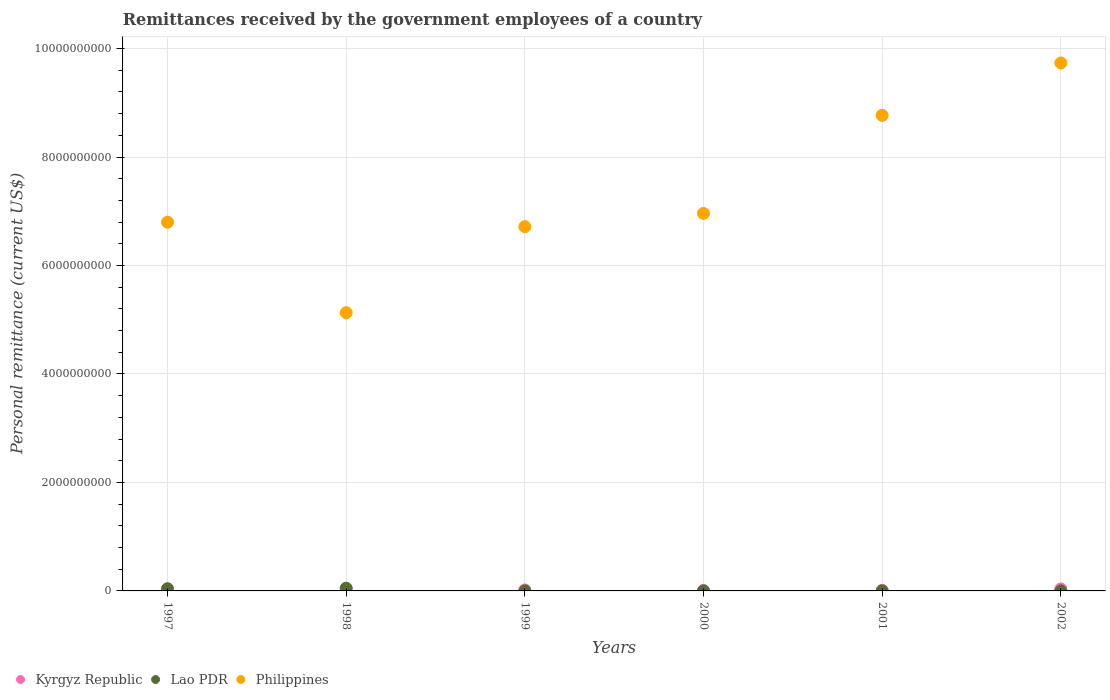How many different coloured dotlines are there?
Make the answer very short. 3. Is the number of dotlines equal to the number of legend labels?
Your response must be concise. Yes. What is the remittances received by the government employees in Philippines in 1999?
Your answer should be compact. 6.72e+09. Across all years, what is the minimum remittances received by the government employees in Lao PDR?
Ensure brevity in your answer.  6.00e+05. In which year was the remittances received by the government employees in Philippines maximum?
Your answer should be compact. 2002. What is the total remittances received by the government employees in Kyrgyz Republic in the graph?
Offer a terse response. 1.03e+08. What is the difference between the remittances received by the government employees in Philippines in 1997 and that in 1999?
Your answer should be very brief. 8.20e+07. What is the difference between the remittances received by the government employees in Philippines in 1999 and the remittances received by the government employees in Kyrgyz Republic in 2001?
Your answer should be very brief. 6.71e+09. What is the average remittances received by the government employees in Kyrgyz Republic per year?
Provide a succinct answer. 1.71e+07. In the year 1997, what is the difference between the remittances received by the government employees in Philippines and remittances received by the government employees in Lao PDR?
Ensure brevity in your answer.  6.76e+09. What is the ratio of the remittances received by the government employees in Kyrgyz Republic in 1997 to that in 2000?
Offer a very short reply. 0.31. Is the difference between the remittances received by the government employees in Philippines in 1997 and 2001 greater than the difference between the remittances received by the government employees in Lao PDR in 1997 and 2001?
Your response must be concise. No. What is the difference between the highest and the second highest remittances received by the government employees in Philippines?
Offer a very short reply. 9.66e+08. What is the difference between the highest and the lowest remittances received by the government employees in Kyrgyz Republic?
Ensure brevity in your answer.  3.40e+07. Is the remittances received by the government employees in Philippines strictly greater than the remittances received by the government employees in Kyrgyz Republic over the years?
Provide a short and direct response. Yes. Is the remittances received by the government employees in Lao PDR strictly less than the remittances received by the government employees in Philippines over the years?
Ensure brevity in your answer.  Yes. How many dotlines are there?
Make the answer very short. 3. How many years are there in the graph?
Give a very brief answer. 6. Are the values on the major ticks of Y-axis written in scientific E-notation?
Offer a terse response. No. Does the graph contain any zero values?
Ensure brevity in your answer.  No. How are the legend labels stacked?
Your answer should be compact. Horizontal. What is the title of the graph?
Provide a short and direct response. Remittances received by the government employees of a country. Does "West Bank and Gaza" appear as one of the legend labels in the graph?
Your answer should be compact. No. What is the label or title of the X-axis?
Your answer should be very brief. Years. What is the label or title of the Y-axis?
Offer a terse response. Personal remittance (current US$). What is the Personal remittance (current US$) of Kyrgyz Republic in 1997?
Ensure brevity in your answer.  2.74e+06. What is the Personal remittance (current US$) of Lao PDR in 1997?
Keep it short and to the point. 4.08e+07. What is the Personal remittance (current US$) of Philippines in 1997?
Keep it short and to the point. 6.80e+09. What is the Personal remittance (current US$) in Kyrgyz Republic in 1998?
Your answer should be very brief. 2.47e+07. What is the Personal remittance (current US$) of Philippines in 1998?
Your response must be concise. 5.13e+09. What is the Personal remittance (current US$) of Kyrgyz Republic in 1999?
Provide a succinct answer. 1.85e+07. What is the Personal remittance (current US$) in Lao PDR in 1999?
Make the answer very short. 6.00e+05. What is the Personal remittance (current US$) in Philippines in 1999?
Ensure brevity in your answer.  6.72e+09. What is the Personal remittance (current US$) of Kyrgyz Republic in 2000?
Your response must be concise. 8.84e+06. What is the Personal remittance (current US$) of Lao PDR in 2000?
Offer a very short reply. 6.60e+05. What is the Personal remittance (current US$) of Philippines in 2000?
Keep it short and to the point. 6.96e+09. What is the Personal remittance (current US$) in Kyrgyz Republic in 2001?
Your answer should be very brief. 1.11e+07. What is the Personal remittance (current US$) of Lao PDR in 2001?
Give a very brief answer. 6.95e+05. What is the Personal remittance (current US$) in Philippines in 2001?
Provide a short and direct response. 8.77e+09. What is the Personal remittance (current US$) in Kyrgyz Republic in 2002?
Make the answer very short. 3.67e+07. What is the Personal remittance (current US$) of Lao PDR in 2002?
Ensure brevity in your answer.  7.29e+05. What is the Personal remittance (current US$) in Philippines in 2002?
Offer a very short reply. 9.74e+09. Across all years, what is the maximum Personal remittance (current US$) in Kyrgyz Republic?
Your response must be concise. 3.67e+07. Across all years, what is the maximum Personal remittance (current US$) in Lao PDR?
Make the answer very short. 5.00e+07. Across all years, what is the maximum Personal remittance (current US$) in Philippines?
Keep it short and to the point. 9.74e+09. Across all years, what is the minimum Personal remittance (current US$) in Kyrgyz Republic?
Give a very brief answer. 2.74e+06. Across all years, what is the minimum Personal remittance (current US$) of Lao PDR?
Ensure brevity in your answer.  6.00e+05. Across all years, what is the minimum Personal remittance (current US$) in Philippines?
Keep it short and to the point. 5.13e+09. What is the total Personal remittance (current US$) of Kyrgyz Republic in the graph?
Offer a very short reply. 1.03e+08. What is the total Personal remittance (current US$) in Lao PDR in the graph?
Offer a terse response. 9.35e+07. What is the total Personal remittance (current US$) in Philippines in the graph?
Make the answer very short. 4.41e+1. What is the difference between the Personal remittance (current US$) of Kyrgyz Republic in 1997 and that in 1998?
Make the answer very short. -2.20e+07. What is the difference between the Personal remittance (current US$) in Lao PDR in 1997 and that in 1998?
Your response must be concise. -9.20e+06. What is the difference between the Personal remittance (current US$) in Philippines in 1997 and that in 1998?
Provide a succinct answer. 1.67e+09. What is the difference between the Personal remittance (current US$) of Kyrgyz Republic in 1997 and that in 1999?
Your answer should be very brief. -1.57e+07. What is the difference between the Personal remittance (current US$) of Lao PDR in 1997 and that in 1999?
Give a very brief answer. 4.02e+07. What is the difference between the Personal remittance (current US$) of Philippines in 1997 and that in 1999?
Offer a very short reply. 8.20e+07. What is the difference between the Personal remittance (current US$) of Kyrgyz Republic in 1997 and that in 2000?
Provide a short and direct response. -6.10e+06. What is the difference between the Personal remittance (current US$) of Lao PDR in 1997 and that in 2000?
Provide a short and direct response. 4.01e+07. What is the difference between the Personal remittance (current US$) of Philippines in 1997 and that in 2000?
Keep it short and to the point. -1.62e+08. What is the difference between the Personal remittance (current US$) of Kyrgyz Republic in 1997 and that in 2001?
Offer a very short reply. -8.37e+06. What is the difference between the Personal remittance (current US$) of Lao PDR in 1997 and that in 2001?
Keep it short and to the point. 4.01e+07. What is the difference between the Personal remittance (current US$) in Philippines in 1997 and that in 2001?
Your answer should be compact. -1.97e+09. What is the difference between the Personal remittance (current US$) of Kyrgyz Republic in 1997 and that in 2002?
Offer a very short reply. -3.40e+07. What is the difference between the Personal remittance (current US$) in Lao PDR in 1997 and that in 2002?
Ensure brevity in your answer.  4.01e+07. What is the difference between the Personal remittance (current US$) of Philippines in 1997 and that in 2002?
Keep it short and to the point. -2.94e+09. What is the difference between the Personal remittance (current US$) in Kyrgyz Republic in 1998 and that in 1999?
Your answer should be compact. 6.22e+06. What is the difference between the Personal remittance (current US$) in Lao PDR in 1998 and that in 1999?
Provide a short and direct response. 4.94e+07. What is the difference between the Personal remittance (current US$) of Philippines in 1998 and that in 1999?
Offer a terse response. -1.59e+09. What is the difference between the Personal remittance (current US$) of Kyrgyz Republic in 1998 and that in 2000?
Your response must be concise. 1.59e+07. What is the difference between the Personal remittance (current US$) of Lao PDR in 1998 and that in 2000?
Your answer should be very brief. 4.93e+07. What is the difference between the Personal remittance (current US$) in Philippines in 1998 and that in 2000?
Provide a short and direct response. -1.83e+09. What is the difference between the Personal remittance (current US$) in Kyrgyz Republic in 1998 and that in 2001?
Provide a succinct answer. 1.36e+07. What is the difference between the Personal remittance (current US$) of Lao PDR in 1998 and that in 2001?
Offer a terse response. 4.93e+07. What is the difference between the Personal remittance (current US$) in Philippines in 1998 and that in 2001?
Your answer should be compact. -3.64e+09. What is the difference between the Personal remittance (current US$) of Kyrgyz Republic in 1998 and that in 2002?
Offer a terse response. -1.20e+07. What is the difference between the Personal remittance (current US$) of Lao PDR in 1998 and that in 2002?
Offer a very short reply. 4.93e+07. What is the difference between the Personal remittance (current US$) in Philippines in 1998 and that in 2002?
Provide a succinct answer. -4.60e+09. What is the difference between the Personal remittance (current US$) in Kyrgyz Republic in 1999 and that in 2000?
Provide a succinct answer. 9.63e+06. What is the difference between the Personal remittance (current US$) of Lao PDR in 1999 and that in 2000?
Offer a terse response. -6.00e+04. What is the difference between the Personal remittance (current US$) in Philippines in 1999 and that in 2000?
Offer a very short reply. -2.44e+08. What is the difference between the Personal remittance (current US$) in Kyrgyz Republic in 1999 and that in 2001?
Provide a succinct answer. 7.36e+06. What is the difference between the Personal remittance (current US$) in Lao PDR in 1999 and that in 2001?
Give a very brief answer. -9.46e+04. What is the difference between the Personal remittance (current US$) of Philippines in 1999 and that in 2001?
Give a very brief answer. -2.05e+09. What is the difference between the Personal remittance (current US$) in Kyrgyz Republic in 1999 and that in 2002?
Keep it short and to the point. -1.82e+07. What is the difference between the Personal remittance (current US$) in Lao PDR in 1999 and that in 2002?
Your response must be concise. -1.29e+05. What is the difference between the Personal remittance (current US$) in Philippines in 1999 and that in 2002?
Ensure brevity in your answer.  -3.02e+09. What is the difference between the Personal remittance (current US$) in Kyrgyz Republic in 2000 and that in 2001?
Keep it short and to the point. -2.27e+06. What is the difference between the Personal remittance (current US$) of Lao PDR in 2000 and that in 2001?
Keep it short and to the point. -3.46e+04. What is the difference between the Personal remittance (current US$) in Philippines in 2000 and that in 2001?
Make the answer very short. -1.81e+09. What is the difference between the Personal remittance (current US$) in Kyrgyz Republic in 2000 and that in 2002?
Your answer should be compact. -2.79e+07. What is the difference between the Personal remittance (current US$) in Lao PDR in 2000 and that in 2002?
Keep it short and to the point. -6.93e+04. What is the difference between the Personal remittance (current US$) of Philippines in 2000 and that in 2002?
Keep it short and to the point. -2.77e+09. What is the difference between the Personal remittance (current US$) in Kyrgyz Republic in 2001 and that in 2002?
Keep it short and to the point. -2.56e+07. What is the difference between the Personal remittance (current US$) of Lao PDR in 2001 and that in 2002?
Keep it short and to the point. -3.47e+04. What is the difference between the Personal remittance (current US$) of Philippines in 2001 and that in 2002?
Ensure brevity in your answer.  -9.66e+08. What is the difference between the Personal remittance (current US$) of Kyrgyz Republic in 1997 and the Personal remittance (current US$) of Lao PDR in 1998?
Ensure brevity in your answer.  -4.73e+07. What is the difference between the Personal remittance (current US$) of Kyrgyz Republic in 1997 and the Personal remittance (current US$) of Philippines in 1998?
Keep it short and to the point. -5.13e+09. What is the difference between the Personal remittance (current US$) of Lao PDR in 1997 and the Personal remittance (current US$) of Philippines in 1998?
Make the answer very short. -5.09e+09. What is the difference between the Personal remittance (current US$) of Kyrgyz Republic in 1997 and the Personal remittance (current US$) of Lao PDR in 1999?
Your response must be concise. 2.14e+06. What is the difference between the Personal remittance (current US$) in Kyrgyz Republic in 1997 and the Personal remittance (current US$) in Philippines in 1999?
Your response must be concise. -6.71e+09. What is the difference between the Personal remittance (current US$) of Lao PDR in 1997 and the Personal remittance (current US$) of Philippines in 1999?
Make the answer very short. -6.68e+09. What is the difference between the Personal remittance (current US$) of Kyrgyz Republic in 1997 and the Personal remittance (current US$) of Lao PDR in 2000?
Ensure brevity in your answer.  2.08e+06. What is the difference between the Personal remittance (current US$) of Kyrgyz Republic in 1997 and the Personal remittance (current US$) of Philippines in 2000?
Your answer should be compact. -6.96e+09. What is the difference between the Personal remittance (current US$) in Lao PDR in 1997 and the Personal remittance (current US$) in Philippines in 2000?
Provide a succinct answer. -6.92e+09. What is the difference between the Personal remittance (current US$) of Kyrgyz Republic in 1997 and the Personal remittance (current US$) of Lao PDR in 2001?
Offer a very short reply. 2.05e+06. What is the difference between the Personal remittance (current US$) of Kyrgyz Republic in 1997 and the Personal remittance (current US$) of Philippines in 2001?
Offer a very short reply. -8.77e+09. What is the difference between the Personal remittance (current US$) in Lao PDR in 1997 and the Personal remittance (current US$) in Philippines in 2001?
Keep it short and to the point. -8.73e+09. What is the difference between the Personal remittance (current US$) of Kyrgyz Republic in 1997 and the Personal remittance (current US$) of Lao PDR in 2002?
Give a very brief answer. 2.01e+06. What is the difference between the Personal remittance (current US$) in Kyrgyz Republic in 1997 and the Personal remittance (current US$) in Philippines in 2002?
Keep it short and to the point. -9.73e+09. What is the difference between the Personal remittance (current US$) in Lao PDR in 1997 and the Personal remittance (current US$) in Philippines in 2002?
Offer a terse response. -9.69e+09. What is the difference between the Personal remittance (current US$) in Kyrgyz Republic in 1998 and the Personal remittance (current US$) in Lao PDR in 1999?
Give a very brief answer. 2.41e+07. What is the difference between the Personal remittance (current US$) of Kyrgyz Republic in 1998 and the Personal remittance (current US$) of Philippines in 1999?
Your response must be concise. -6.69e+09. What is the difference between the Personal remittance (current US$) in Lao PDR in 1998 and the Personal remittance (current US$) in Philippines in 1999?
Provide a short and direct response. -6.67e+09. What is the difference between the Personal remittance (current US$) of Kyrgyz Republic in 1998 and the Personal remittance (current US$) of Lao PDR in 2000?
Provide a succinct answer. 2.40e+07. What is the difference between the Personal remittance (current US$) of Kyrgyz Republic in 1998 and the Personal remittance (current US$) of Philippines in 2000?
Your response must be concise. -6.94e+09. What is the difference between the Personal remittance (current US$) in Lao PDR in 1998 and the Personal remittance (current US$) in Philippines in 2000?
Make the answer very short. -6.91e+09. What is the difference between the Personal remittance (current US$) of Kyrgyz Republic in 1998 and the Personal remittance (current US$) of Lao PDR in 2001?
Ensure brevity in your answer.  2.40e+07. What is the difference between the Personal remittance (current US$) of Kyrgyz Republic in 1998 and the Personal remittance (current US$) of Philippines in 2001?
Ensure brevity in your answer.  -8.74e+09. What is the difference between the Personal remittance (current US$) in Lao PDR in 1998 and the Personal remittance (current US$) in Philippines in 2001?
Give a very brief answer. -8.72e+09. What is the difference between the Personal remittance (current US$) of Kyrgyz Republic in 1998 and the Personal remittance (current US$) of Lao PDR in 2002?
Your response must be concise. 2.40e+07. What is the difference between the Personal remittance (current US$) of Kyrgyz Republic in 1998 and the Personal remittance (current US$) of Philippines in 2002?
Offer a terse response. -9.71e+09. What is the difference between the Personal remittance (current US$) in Lao PDR in 1998 and the Personal remittance (current US$) in Philippines in 2002?
Offer a terse response. -9.68e+09. What is the difference between the Personal remittance (current US$) of Kyrgyz Republic in 1999 and the Personal remittance (current US$) of Lao PDR in 2000?
Offer a terse response. 1.78e+07. What is the difference between the Personal remittance (current US$) of Kyrgyz Republic in 1999 and the Personal remittance (current US$) of Philippines in 2000?
Your response must be concise. -6.94e+09. What is the difference between the Personal remittance (current US$) in Lao PDR in 1999 and the Personal remittance (current US$) in Philippines in 2000?
Ensure brevity in your answer.  -6.96e+09. What is the difference between the Personal remittance (current US$) of Kyrgyz Republic in 1999 and the Personal remittance (current US$) of Lao PDR in 2001?
Make the answer very short. 1.78e+07. What is the difference between the Personal remittance (current US$) of Kyrgyz Republic in 1999 and the Personal remittance (current US$) of Philippines in 2001?
Keep it short and to the point. -8.75e+09. What is the difference between the Personal remittance (current US$) of Lao PDR in 1999 and the Personal remittance (current US$) of Philippines in 2001?
Make the answer very short. -8.77e+09. What is the difference between the Personal remittance (current US$) in Kyrgyz Republic in 1999 and the Personal remittance (current US$) in Lao PDR in 2002?
Your answer should be compact. 1.77e+07. What is the difference between the Personal remittance (current US$) of Kyrgyz Republic in 1999 and the Personal remittance (current US$) of Philippines in 2002?
Offer a very short reply. -9.72e+09. What is the difference between the Personal remittance (current US$) of Lao PDR in 1999 and the Personal remittance (current US$) of Philippines in 2002?
Offer a terse response. -9.73e+09. What is the difference between the Personal remittance (current US$) in Kyrgyz Republic in 2000 and the Personal remittance (current US$) in Lao PDR in 2001?
Provide a short and direct response. 8.15e+06. What is the difference between the Personal remittance (current US$) in Kyrgyz Republic in 2000 and the Personal remittance (current US$) in Philippines in 2001?
Offer a terse response. -8.76e+09. What is the difference between the Personal remittance (current US$) in Lao PDR in 2000 and the Personal remittance (current US$) in Philippines in 2001?
Your answer should be compact. -8.77e+09. What is the difference between the Personal remittance (current US$) of Kyrgyz Republic in 2000 and the Personal remittance (current US$) of Lao PDR in 2002?
Offer a terse response. 8.12e+06. What is the difference between the Personal remittance (current US$) of Kyrgyz Republic in 2000 and the Personal remittance (current US$) of Philippines in 2002?
Your answer should be very brief. -9.73e+09. What is the difference between the Personal remittance (current US$) in Lao PDR in 2000 and the Personal remittance (current US$) in Philippines in 2002?
Keep it short and to the point. -9.73e+09. What is the difference between the Personal remittance (current US$) in Kyrgyz Republic in 2001 and the Personal remittance (current US$) in Lao PDR in 2002?
Make the answer very short. 1.04e+07. What is the difference between the Personal remittance (current US$) in Kyrgyz Republic in 2001 and the Personal remittance (current US$) in Philippines in 2002?
Your response must be concise. -9.72e+09. What is the difference between the Personal remittance (current US$) of Lao PDR in 2001 and the Personal remittance (current US$) of Philippines in 2002?
Ensure brevity in your answer.  -9.73e+09. What is the average Personal remittance (current US$) in Kyrgyz Republic per year?
Make the answer very short. 1.71e+07. What is the average Personal remittance (current US$) in Lao PDR per year?
Your response must be concise. 1.56e+07. What is the average Personal remittance (current US$) in Philippines per year?
Offer a very short reply. 7.35e+09. In the year 1997, what is the difference between the Personal remittance (current US$) in Kyrgyz Republic and Personal remittance (current US$) in Lao PDR?
Provide a succinct answer. -3.81e+07. In the year 1997, what is the difference between the Personal remittance (current US$) in Kyrgyz Republic and Personal remittance (current US$) in Philippines?
Offer a very short reply. -6.80e+09. In the year 1997, what is the difference between the Personal remittance (current US$) in Lao PDR and Personal remittance (current US$) in Philippines?
Ensure brevity in your answer.  -6.76e+09. In the year 1998, what is the difference between the Personal remittance (current US$) in Kyrgyz Republic and Personal remittance (current US$) in Lao PDR?
Provide a short and direct response. -2.53e+07. In the year 1998, what is the difference between the Personal remittance (current US$) in Kyrgyz Republic and Personal remittance (current US$) in Philippines?
Ensure brevity in your answer.  -5.11e+09. In the year 1998, what is the difference between the Personal remittance (current US$) in Lao PDR and Personal remittance (current US$) in Philippines?
Ensure brevity in your answer.  -5.08e+09. In the year 1999, what is the difference between the Personal remittance (current US$) in Kyrgyz Republic and Personal remittance (current US$) in Lao PDR?
Keep it short and to the point. 1.79e+07. In the year 1999, what is the difference between the Personal remittance (current US$) in Kyrgyz Republic and Personal remittance (current US$) in Philippines?
Keep it short and to the point. -6.70e+09. In the year 1999, what is the difference between the Personal remittance (current US$) in Lao PDR and Personal remittance (current US$) in Philippines?
Make the answer very short. -6.72e+09. In the year 2000, what is the difference between the Personal remittance (current US$) of Kyrgyz Republic and Personal remittance (current US$) of Lao PDR?
Provide a short and direct response. 8.18e+06. In the year 2000, what is the difference between the Personal remittance (current US$) in Kyrgyz Republic and Personal remittance (current US$) in Philippines?
Keep it short and to the point. -6.95e+09. In the year 2000, what is the difference between the Personal remittance (current US$) in Lao PDR and Personal remittance (current US$) in Philippines?
Provide a short and direct response. -6.96e+09. In the year 2001, what is the difference between the Personal remittance (current US$) of Kyrgyz Republic and Personal remittance (current US$) of Lao PDR?
Provide a short and direct response. 1.04e+07. In the year 2001, what is the difference between the Personal remittance (current US$) in Kyrgyz Republic and Personal remittance (current US$) in Philippines?
Your response must be concise. -8.76e+09. In the year 2001, what is the difference between the Personal remittance (current US$) in Lao PDR and Personal remittance (current US$) in Philippines?
Your answer should be compact. -8.77e+09. In the year 2002, what is the difference between the Personal remittance (current US$) of Kyrgyz Republic and Personal remittance (current US$) of Lao PDR?
Provide a short and direct response. 3.60e+07. In the year 2002, what is the difference between the Personal remittance (current US$) in Kyrgyz Republic and Personal remittance (current US$) in Philippines?
Provide a succinct answer. -9.70e+09. In the year 2002, what is the difference between the Personal remittance (current US$) in Lao PDR and Personal remittance (current US$) in Philippines?
Offer a terse response. -9.73e+09. What is the ratio of the Personal remittance (current US$) of Kyrgyz Republic in 1997 to that in 1998?
Your answer should be compact. 0.11. What is the ratio of the Personal remittance (current US$) in Lao PDR in 1997 to that in 1998?
Keep it short and to the point. 0.82. What is the ratio of the Personal remittance (current US$) in Philippines in 1997 to that in 1998?
Make the answer very short. 1.33. What is the ratio of the Personal remittance (current US$) of Kyrgyz Republic in 1997 to that in 1999?
Keep it short and to the point. 0.15. What is the ratio of the Personal remittance (current US$) in Philippines in 1997 to that in 1999?
Provide a short and direct response. 1.01. What is the ratio of the Personal remittance (current US$) in Kyrgyz Republic in 1997 to that in 2000?
Your answer should be compact. 0.31. What is the ratio of the Personal remittance (current US$) of Lao PDR in 1997 to that in 2000?
Your answer should be compact. 61.82. What is the ratio of the Personal remittance (current US$) in Philippines in 1997 to that in 2000?
Your answer should be compact. 0.98. What is the ratio of the Personal remittance (current US$) of Kyrgyz Republic in 1997 to that in 2001?
Ensure brevity in your answer.  0.25. What is the ratio of the Personal remittance (current US$) in Lao PDR in 1997 to that in 2001?
Your answer should be very brief. 58.74. What is the ratio of the Personal remittance (current US$) of Philippines in 1997 to that in 2001?
Offer a terse response. 0.78. What is the ratio of the Personal remittance (current US$) of Kyrgyz Republic in 1997 to that in 2002?
Keep it short and to the point. 0.07. What is the ratio of the Personal remittance (current US$) of Lao PDR in 1997 to that in 2002?
Make the answer very short. 55.94. What is the ratio of the Personal remittance (current US$) of Philippines in 1997 to that in 2002?
Your answer should be compact. 0.7. What is the ratio of the Personal remittance (current US$) of Kyrgyz Republic in 1998 to that in 1999?
Ensure brevity in your answer.  1.34. What is the ratio of the Personal remittance (current US$) of Lao PDR in 1998 to that in 1999?
Provide a succinct answer. 83.33. What is the ratio of the Personal remittance (current US$) in Philippines in 1998 to that in 1999?
Give a very brief answer. 0.76. What is the ratio of the Personal remittance (current US$) in Kyrgyz Republic in 1998 to that in 2000?
Ensure brevity in your answer.  2.79. What is the ratio of the Personal remittance (current US$) in Lao PDR in 1998 to that in 2000?
Keep it short and to the point. 75.76. What is the ratio of the Personal remittance (current US$) in Philippines in 1998 to that in 2000?
Offer a very short reply. 0.74. What is the ratio of the Personal remittance (current US$) in Kyrgyz Republic in 1998 to that in 2001?
Your answer should be compact. 2.22. What is the ratio of the Personal remittance (current US$) of Lao PDR in 1998 to that in 2001?
Give a very brief answer. 71.99. What is the ratio of the Personal remittance (current US$) in Philippines in 1998 to that in 2001?
Your answer should be compact. 0.58. What is the ratio of the Personal remittance (current US$) in Kyrgyz Republic in 1998 to that in 2002?
Give a very brief answer. 0.67. What is the ratio of the Personal remittance (current US$) of Lao PDR in 1998 to that in 2002?
Your answer should be very brief. 68.56. What is the ratio of the Personal remittance (current US$) in Philippines in 1998 to that in 2002?
Your response must be concise. 0.53. What is the ratio of the Personal remittance (current US$) of Kyrgyz Republic in 1999 to that in 2000?
Your response must be concise. 2.09. What is the ratio of the Personal remittance (current US$) in Philippines in 1999 to that in 2000?
Make the answer very short. 0.96. What is the ratio of the Personal remittance (current US$) of Kyrgyz Republic in 1999 to that in 2001?
Offer a very short reply. 1.66. What is the ratio of the Personal remittance (current US$) in Lao PDR in 1999 to that in 2001?
Ensure brevity in your answer.  0.86. What is the ratio of the Personal remittance (current US$) in Philippines in 1999 to that in 2001?
Keep it short and to the point. 0.77. What is the ratio of the Personal remittance (current US$) in Kyrgyz Republic in 1999 to that in 2002?
Make the answer very short. 0.5. What is the ratio of the Personal remittance (current US$) in Lao PDR in 1999 to that in 2002?
Your response must be concise. 0.82. What is the ratio of the Personal remittance (current US$) in Philippines in 1999 to that in 2002?
Your answer should be compact. 0.69. What is the ratio of the Personal remittance (current US$) of Kyrgyz Republic in 2000 to that in 2001?
Provide a succinct answer. 0.8. What is the ratio of the Personal remittance (current US$) of Lao PDR in 2000 to that in 2001?
Your answer should be very brief. 0.95. What is the ratio of the Personal remittance (current US$) of Philippines in 2000 to that in 2001?
Offer a very short reply. 0.79. What is the ratio of the Personal remittance (current US$) of Kyrgyz Republic in 2000 to that in 2002?
Provide a short and direct response. 0.24. What is the ratio of the Personal remittance (current US$) in Lao PDR in 2000 to that in 2002?
Provide a short and direct response. 0.91. What is the ratio of the Personal remittance (current US$) of Philippines in 2000 to that in 2002?
Provide a short and direct response. 0.71. What is the ratio of the Personal remittance (current US$) in Kyrgyz Republic in 2001 to that in 2002?
Provide a succinct answer. 0.3. What is the ratio of the Personal remittance (current US$) in Lao PDR in 2001 to that in 2002?
Your answer should be very brief. 0.95. What is the ratio of the Personal remittance (current US$) in Philippines in 2001 to that in 2002?
Ensure brevity in your answer.  0.9. What is the difference between the highest and the second highest Personal remittance (current US$) of Kyrgyz Republic?
Your answer should be compact. 1.20e+07. What is the difference between the highest and the second highest Personal remittance (current US$) in Lao PDR?
Ensure brevity in your answer.  9.20e+06. What is the difference between the highest and the second highest Personal remittance (current US$) in Philippines?
Your answer should be compact. 9.66e+08. What is the difference between the highest and the lowest Personal remittance (current US$) of Kyrgyz Republic?
Make the answer very short. 3.40e+07. What is the difference between the highest and the lowest Personal remittance (current US$) in Lao PDR?
Offer a very short reply. 4.94e+07. What is the difference between the highest and the lowest Personal remittance (current US$) in Philippines?
Offer a very short reply. 4.60e+09. 